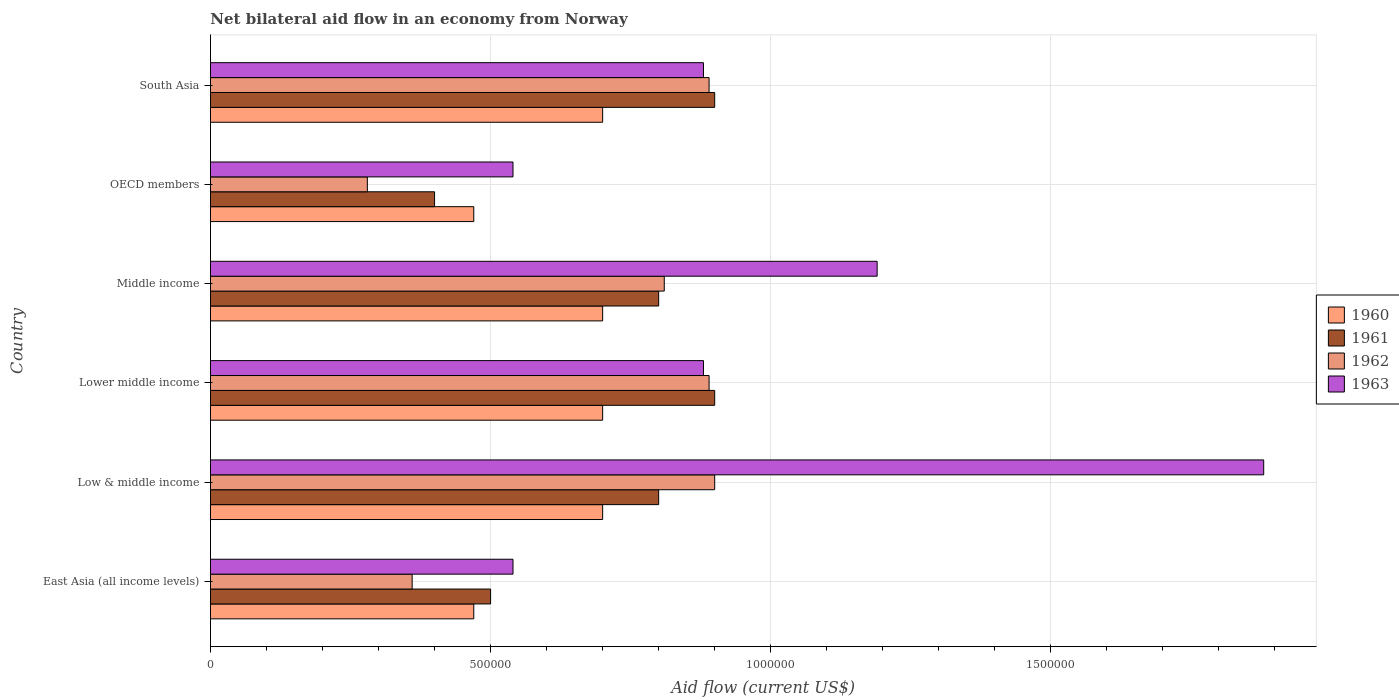How many groups of bars are there?
Provide a short and direct response. 6. Are the number of bars per tick equal to the number of legend labels?
Your response must be concise. Yes. What is the label of the 6th group of bars from the top?
Give a very brief answer. East Asia (all income levels). What is the net bilateral aid flow in 1963 in Lower middle income?
Your response must be concise. 8.80e+05. Across all countries, what is the minimum net bilateral aid flow in 1961?
Provide a short and direct response. 4.00e+05. In which country was the net bilateral aid flow in 1963 minimum?
Your answer should be very brief. East Asia (all income levels). What is the total net bilateral aid flow in 1960 in the graph?
Make the answer very short. 3.74e+06. What is the difference between the net bilateral aid flow in 1960 in East Asia (all income levels) and that in OECD members?
Keep it short and to the point. 0. What is the difference between the net bilateral aid flow in 1962 in OECD members and the net bilateral aid flow in 1960 in Middle income?
Give a very brief answer. -4.20e+05. What is the average net bilateral aid flow in 1962 per country?
Your answer should be very brief. 6.88e+05. In how many countries, is the net bilateral aid flow in 1962 greater than 100000 US$?
Provide a short and direct response. 6. What is the difference between the highest and the second highest net bilateral aid flow in 1963?
Your answer should be very brief. 6.90e+05. What is the difference between the highest and the lowest net bilateral aid flow in 1960?
Offer a terse response. 2.30e+05. Is the sum of the net bilateral aid flow in 1960 in Low & middle income and Lower middle income greater than the maximum net bilateral aid flow in 1962 across all countries?
Make the answer very short. Yes. Is it the case that in every country, the sum of the net bilateral aid flow in 1960 and net bilateral aid flow in 1962 is greater than the sum of net bilateral aid flow in 1961 and net bilateral aid flow in 1963?
Give a very brief answer. No. Is it the case that in every country, the sum of the net bilateral aid flow in 1961 and net bilateral aid flow in 1960 is greater than the net bilateral aid flow in 1962?
Keep it short and to the point. Yes. How many bars are there?
Offer a terse response. 24. Are all the bars in the graph horizontal?
Your answer should be very brief. Yes. How many countries are there in the graph?
Offer a very short reply. 6. Are the values on the major ticks of X-axis written in scientific E-notation?
Offer a very short reply. No. Does the graph contain grids?
Offer a terse response. Yes. Where does the legend appear in the graph?
Provide a succinct answer. Center right. What is the title of the graph?
Ensure brevity in your answer.  Net bilateral aid flow in an economy from Norway. What is the Aid flow (current US$) in 1963 in East Asia (all income levels)?
Keep it short and to the point. 5.40e+05. What is the Aid flow (current US$) of 1960 in Low & middle income?
Offer a terse response. 7.00e+05. What is the Aid flow (current US$) of 1961 in Low & middle income?
Keep it short and to the point. 8.00e+05. What is the Aid flow (current US$) of 1963 in Low & middle income?
Offer a very short reply. 1.88e+06. What is the Aid flow (current US$) in 1960 in Lower middle income?
Provide a succinct answer. 7.00e+05. What is the Aid flow (current US$) of 1961 in Lower middle income?
Your answer should be very brief. 9.00e+05. What is the Aid flow (current US$) in 1962 in Lower middle income?
Keep it short and to the point. 8.90e+05. What is the Aid flow (current US$) in 1963 in Lower middle income?
Your response must be concise. 8.80e+05. What is the Aid flow (current US$) of 1962 in Middle income?
Ensure brevity in your answer.  8.10e+05. What is the Aid flow (current US$) in 1963 in Middle income?
Keep it short and to the point. 1.19e+06. What is the Aid flow (current US$) of 1960 in OECD members?
Offer a very short reply. 4.70e+05. What is the Aid flow (current US$) of 1961 in OECD members?
Provide a short and direct response. 4.00e+05. What is the Aid flow (current US$) in 1962 in OECD members?
Make the answer very short. 2.80e+05. What is the Aid flow (current US$) of 1963 in OECD members?
Your response must be concise. 5.40e+05. What is the Aid flow (current US$) in 1960 in South Asia?
Your answer should be compact. 7.00e+05. What is the Aid flow (current US$) in 1961 in South Asia?
Your answer should be very brief. 9.00e+05. What is the Aid flow (current US$) of 1962 in South Asia?
Ensure brevity in your answer.  8.90e+05. What is the Aid flow (current US$) of 1963 in South Asia?
Give a very brief answer. 8.80e+05. Across all countries, what is the maximum Aid flow (current US$) of 1960?
Offer a very short reply. 7.00e+05. Across all countries, what is the maximum Aid flow (current US$) of 1962?
Provide a succinct answer. 9.00e+05. Across all countries, what is the maximum Aid flow (current US$) in 1963?
Your answer should be very brief. 1.88e+06. Across all countries, what is the minimum Aid flow (current US$) of 1960?
Your answer should be compact. 4.70e+05. Across all countries, what is the minimum Aid flow (current US$) in 1961?
Your response must be concise. 4.00e+05. Across all countries, what is the minimum Aid flow (current US$) of 1962?
Provide a short and direct response. 2.80e+05. Across all countries, what is the minimum Aid flow (current US$) in 1963?
Provide a short and direct response. 5.40e+05. What is the total Aid flow (current US$) of 1960 in the graph?
Your answer should be compact. 3.74e+06. What is the total Aid flow (current US$) of 1961 in the graph?
Make the answer very short. 4.30e+06. What is the total Aid flow (current US$) of 1962 in the graph?
Give a very brief answer. 4.13e+06. What is the total Aid flow (current US$) in 1963 in the graph?
Offer a terse response. 5.91e+06. What is the difference between the Aid flow (current US$) in 1962 in East Asia (all income levels) and that in Low & middle income?
Ensure brevity in your answer.  -5.40e+05. What is the difference between the Aid flow (current US$) of 1963 in East Asia (all income levels) and that in Low & middle income?
Your response must be concise. -1.34e+06. What is the difference between the Aid flow (current US$) in 1960 in East Asia (all income levels) and that in Lower middle income?
Offer a terse response. -2.30e+05. What is the difference between the Aid flow (current US$) in 1961 in East Asia (all income levels) and that in Lower middle income?
Your answer should be compact. -4.00e+05. What is the difference between the Aid flow (current US$) of 1962 in East Asia (all income levels) and that in Lower middle income?
Make the answer very short. -5.30e+05. What is the difference between the Aid flow (current US$) of 1963 in East Asia (all income levels) and that in Lower middle income?
Provide a succinct answer. -3.40e+05. What is the difference between the Aid flow (current US$) of 1962 in East Asia (all income levels) and that in Middle income?
Your answer should be compact. -4.50e+05. What is the difference between the Aid flow (current US$) of 1963 in East Asia (all income levels) and that in Middle income?
Provide a succinct answer. -6.50e+05. What is the difference between the Aid flow (current US$) in 1961 in East Asia (all income levels) and that in OECD members?
Provide a short and direct response. 1.00e+05. What is the difference between the Aid flow (current US$) of 1962 in East Asia (all income levels) and that in OECD members?
Provide a succinct answer. 8.00e+04. What is the difference between the Aid flow (current US$) of 1961 in East Asia (all income levels) and that in South Asia?
Keep it short and to the point. -4.00e+05. What is the difference between the Aid flow (current US$) in 1962 in East Asia (all income levels) and that in South Asia?
Offer a terse response. -5.30e+05. What is the difference between the Aid flow (current US$) of 1961 in Low & middle income and that in Middle income?
Provide a succinct answer. 0. What is the difference between the Aid flow (current US$) of 1963 in Low & middle income and that in Middle income?
Offer a very short reply. 6.90e+05. What is the difference between the Aid flow (current US$) in 1960 in Low & middle income and that in OECD members?
Ensure brevity in your answer.  2.30e+05. What is the difference between the Aid flow (current US$) of 1962 in Low & middle income and that in OECD members?
Make the answer very short. 6.20e+05. What is the difference between the Aid flow (current US$) of 1963 in Low & middle income and that in OECD members?
Offer a terse response. 1.34e+06. What is the difference between the Aid flow (current US$) of 1960 in Low & middle income and that in South Asia?
Your answer should be compact. 0. What is the difference between the Aid flow (current US$) of 1963 in Low & middle income and that in South Asia?
Provide a succinct answer. 1.00e+06. What is the difference between the Aid flow (current US$) in 1960 in Lower middle income and that in Middle income?
Your answer should be very brief. 0. What is the difference between the Aid flow (current US$) in 1961 in Lower middle income and that in Middle income?
Offer a terse response. 1.00e+05. What is the difference between the Aid flow (current US$) in 1962 in Lower middle income and that in Middle income?
Give a very brief answer. 8.00e+04. What is the difference between the Aid flow (current US$) of 1963 in Lower middle income and that in Middle income?
Make the answer very short. -3.10e+05. What is the difference between the Aid flow (current US$) of 1961 in Lower middle income and that in OECD members?
Your answer should be very brief. 5.00e+05. What is the difference between the Aid flow (current US$) in 1962 in Lower middle income and that in OECD members?
Ensure brevity in your answer.  6.10e+05. What is the difference between the Aid flow (current US$) of 1963 in Lower middle income and that in OECD members?
Your response must be concise. 3.40e+05. What is the difference between the Aid flow (current US$) of 1960 in Lower middle income and that in South Asia?
Your response must be concise. 0. What is the difference between the Aid flow (current US$) in 1962 in Lower middle income and that in South Asia?
Offer a very short reply. 0. What is the difference between the Aid flow (current US$) in 1963 in Lower middle income and that in South Asia?
Offer a terse response. 0. What is the difference between the Aid flow (current US$) of 1962 in Middle income and that in OECD members?
Give a very brief answer. 5.30e+05. What is the difference between the Aid flow (current US$) in 1963 in Middle income and that in OECD members?
Your answer should be compact. 6.50e+05. What is the difference between the Aid flow (current US$) in 1963 in Middle income and that in South Asia?
Ensure brevity in your answer.  3.10e+05. What is the difference between the Aid flow (current US$) in 1960 in OECD members and that in South Asia?
Your response must be concise. -2.30e+05. What is the difference between the Aid flow (current US$) of 1961 in OECD members and that in South Asia?
Offer a terse response. -5.00e+05. What is the difference between the Aid flow (current US$) of 1962 in OECD members and that in South Asia?
Your response must be concise. -6.10e+05. What is the difference between the Aid flow (current US$) of 1963 in OECD members and that in South Asia?
Keep it short and to the point. -3.40e+05. What is the difference between the Aid flow (current US$) in 1960 in East Asia (all income levels) and the Aid flow (current US$) in 1961 in Low & middle income?
Offer a terse response. -3.30e+05. What is the difference between the Aid flow (current US$) in 1960 in East Asia (all income levels) and the Aid flow (current US$) in 1962 in Low & middle income?
Your response must be concise. -4.30e+05. What is the difference between the Aid flow (current US$) in 1960 in East Asia (all income levels) and the Aid flow (current US$) in 1963 in Low & middle income?
Ensure brevity in your answer.  -1.41e+06. What is the difference between the Aid flow (current US$) in 1961 in East Asia (all income levels) and the Aid flow (current US$) in 1962 in Low & middle income?
Provide a short and direct response. -4.00e+05. What is the difference between the Aid flow (current US$) of 1961 in East Asia (all income levels) and the Aid flow (current US$) of 1963 in Low & middle income?
Offer a terse response. -1.38e+06. What is the difference between the Aid flow (current US$) of 1962 in East Asia (all income levels) and the Aid flow (current US$) of 1963 in Low & middle income?
Keep it short and to the point. -1.52e+06. What is the difference between the Aid flow (current US$) in 1960 in East Asia (all income levels) and the Aid flow (current US$) in 1961 in Lower middle income?
Your response must be concise. -4.30e+05. What is the difference between the Aid flow (current US$) of 1960 in East Asia (all income levels) and the Aid flow (current US$) of 1962 in Lower middle income?
Offer a very short reply. -4.20e+05. What is the difference between the Aid flow (current US$) in 1960 in East Asia (all income levels) and the Aid flow (current US$) in 1963 in Lower middle income?
Offer a very short reply. -4.10e+05. What is the difference between the Aid flow (current US$) in 1961 in East Asia (all income levels) and the Aid flow (current US$) in 1962 in Lower middle income?
Make the answer very short. -3.90e+05. What is the difference between the Aid flow (current US$) in 1961 in East Asia (all income levels) and the Aid flow (current US$) in 1963 in Lower middle income?
Your answer should be compact. -3.80e+05. What is the difference between the Aid flow (current US$) in 1962 in East Asia (all income levels) and the Aid flow (current US$) in 1963 in Lower middle income?
Make the answer very short. -5.20e+05. What is the difference between the Aid flow (current US$) of 1960 in East Asia (all income levels) and the Aid flow (current US$) of 1961 in Middle income?
Your answer should be very brief. -3.30e+05. What is the difference between the Aid flow (current US$) of 1960 in East Asia (all income levels) and the Aid flow (current US$) of 1963 in Middle income?
Offer a very short reply. -7.20e+05. What is the difference between the Aid flow (current US$) in 1961 in East Asia (all income levels) and the Aid flow (current US$) in 1962 in Middle income?
Give a very brief answer. -3.10e+05. What is the difference between the Aid flow (current US$) of 1961 in East Asia (all income levels) and the Aid flow (current US$) of 1963 in Middle income?
Provide a succinct answer. -6.90e+05. What is the difference between the Aid flow (current US$) of 1962 in East Asia (all income levels) and the Aid flow (current US$) of 1963 in Middle income?
Make the answer very short. -8.30e+05. What is the difference between the Aid flow (current US$) of 1961 in East Asia (all income levels) and the Aid flow (current US$) of 1962 in OECD members?
Ensure brevity in your answer.  2.20e+05. What is the difference between the Aid flow (current US$) of 1961 in East Asia (all income levels) and the Aid flow (current US$) of 1963 in OECD members?
Your answer should be compact. -4.00e+04. What is the difference between the Aid flow (current US$) in 1962 in East Asia (all income levels) and the Aid flow (current US$) in 1963 in OECD members?
Your answer should be compact. -1.80e+05. What is the difference between the Aid flow (current US$) of 1960 in East Asia (all income levels) and the Aid flow (current US$) of 1961 in South Asia?
Offer a terse response. -4.30e+05. What is the difference between the Aid flow (current US$) of 1960 in East Asia (all income levels) and the Aid flow (current US$) of 1962 in South Asia?
Offer a very short reply. -4.20e+05. What is the difference between the Aid flow (current US$) of 1960 in East Asia (all income levels) and the Aid flow (current US$) of 1963 in South Asia?
Provide a short and direct response. -4.10e+05. What is the difference between the Aid flow (current US$) in 1961 in East Asia (all income levels) and the Aid flow (current US$) in 1962 in South Asia?
Your response must be concise. -3.90e+05. What is the difference between the Aid flow (current US$) in 1961 in East Asia (all income levels) and the Aid flow (current US$) in 1963 in South Asia?
Keep it short and to the point. -3.80e+05. What is the difference between the Aid flow (current US$) of 1962 in East Asia (all income levels) and the Aid flow (current US$) of 1963 in South Asia?
Ensure brevity in your answer.  -5.20e+05. What is the difference between the Aid flow (current US$) of 1960 in Low & middle income and the Aid flow (current US$) of 1961 in Lower middle income?
Your response must be concise. -2.00e+05. What is the difference between the Aid flow (current US$) in 1961 in Low & middle income and the Aid flow (current US$) in 1963 in Lower middle income?
Make the answer very short. -8.00e+04. What is the difference between the Aid flow (current US$) in 1962 in Low & middle income and the Aid flow (current US$) in 1963 in Lower middle income?
Your answer should be compact. 2.00e+04. What is the difference between the Aid flow (current US$) in 1960 in Low & middle income and the Aid flow (current US$) in 1962 in Middle income?
Make the answer very short. -1.10e+05. What is the difference between the Aid flow (current US$) of 1960 in Low & middle income and the Aid flow (current US$) of 1963 in Middle income?
Offer a terse response. -4.90e+05. What is the difference between the Aid flow (current US$) of 1961 in Low & middle income and the Aid flow (current US$) of 1963 in Middle income?
Offer a very short reply. -3.90e+05. What is the difference between the Aid flow (current US$) in 1962 in Low & middle income and the Aid flow (current US$) in 1963 in Middle income?
Your answer should be very brief. -2.90e+05. What is the difference between the Aid flow (current US$) in 1960 in Low & middle income and the Aid flow (current US$) in 1962 in OECD members?
Your answer should be very brief. 4.20e+05. What is the difference between the Aid flow (current US$) in 1960 in Low & middle income and the Aid flow (current US$) in 1963 in OECD members?
Your answer should be compact. 1.60e+05. What is the difference between the Aid flow (current US$) of 1961 in Low & middle income and the Aid flow (current US$) of 1962 in OECD members?
Provide a short and direct response. 5.20e+05. What is the difference between the Aid flow (current US$) of 1960 in Low & middle income and the Aid flow (current US$) of 1961 in South Asia?
Keep it short and to the point. -2.00e+05. What is the difference between the Aid flow (current US$) of 1960 in Low & middle income and the Aid flow (current US$) of 1962 in South Asia?
Your response must be concise. -1.90e+05. What is the difference between the Aid flow (current US$) of 1962 in Low & middle income and the Aid flow (current US$) of 1963 in South Asia?
Offer a terse response. 2.00e+04. What is the difference between the Aid flow (current US$) of 1960 in Lower middle income and the Aid flow (current US$) of 1961 in Middle income?
Make the answer very short. -1.00e+05. What is the difference between the Aid flow (current US$) in 1960 in Lower middle income and the Aid flow (current US$) in 1963 in Middle income?
Ensure brevity in your answer.  -4.90e+05. What is the difference between the Aid flow (current US$) in 1961 in Lower middle income and the Aid flow (current US$) in 1962 in Middle income?
Provide a succinct answer. 9.00e+04. What is the difference between the Aid flow (current US$) of 1960 in Lower middle income and the Aid flow (current US$) of 1961 in OECD members?
Offer a terse response. 3.00e+05. What is the difference between the Aid flow (current US$) of 1961 in Lower middle income and the Aid flow (current US$) of 1962 in OECD members?
Ensure brevity in your answer.  6.20e+05. What is the difference between the Aid flow (current US$) in 1961 in Lower middle income and the Aid flow (current US$) in 1963 in OECD members?
Your answer should be compact. 3.60e+05. What is the difference between the Aid flow (current US$) in 1962 in Lower middle income and the Aid flow (current US$) in 1963 in OECD members?
Give a very brief answer. 3.50e+05. What is the difference between the Aid flow (current US$) of 1960 in Lower middle income and the Aid flow (current US$) of 1963 in South Asia?
Provide a short and direct response. -1.80e+05. What is the difference between the Aid flow (current US$) in 1961 in Lower middle income and the Aid flow (current US$) in 1963 in South Asia?
Make the answer very short. 2.00e+04. What is the difference between the Aid flow (current US$) in 1960 in Middle income and the Aid flow (current US$) in 1961 in OECD members?
Provide a succinct answer. 3.00e+05. What is the difference between the Aid flow (current US$) in 1960 in Middle income and the Aid flow (current US$) in 1962 in OECD members?
Provide a succinct answer. 4.20e+05. What is the difference between the Aid flow (current US$) of 1961 in Middle income and the Aid flow (current US$) of 1962 in OECD members?
Ensure brevity in your answer.  5.20e+05. What is the difference between the Aid flow (current US$) of 1960 in Middle income and the Aid flow (current US$) of 1963 in South Asia?
Offer a very short reply. -1.80e+05. What is the difference between the Aid flow (current US$) in 1961 in Middle income and the Aid flow (current US$) in 1963 in South Asia?
Your answer should be very brief. -8.00e+04. What is the difference between the Aid flow (current US$) in 1960 in OECD members and the Aid flow (current US$) in 1961 in South Asia?
Offer a very short reply. -4.30e+05. What is the difference between the Aid flow (current US$) in 1960 in OECD members and the Aid flow (current US$) in 1962 in South Asia?
Offer a very short reply. -4.20e+05. What is the difference between the Aid flow (current US$) of 1960 in OECD members and the Aid flow (current US$) of 1963 in South Asia?
Your response must be concise. -4.10e+05. What is the difference between the Aid flow (current US$) in 1961 in OECD members and the Aid flow (current US$) in 1962 in South Asia?
Your answer should be very brief. -4.90e+05. What is the difference between the Aid flow (current US$) in 1961 in OECD members and the Aid flow (current US$) in 1963 in South Asia?
Your answer should be very brief. -4.80e+05. What is the difference between the Aid flow (current US$) of 1962 in OECD members and the Aid flow (current US$) of 1963 in South Asia?
Provide a short and direct response. -6.00e+05. What is the average Aid flow (current US$) in 1960 per country?
Keep it short and to the point. 6.23e+05. What is the average Aid flow (current US$) in 1961 per country?
Give a very brief answer. 7.17e+05. What is the average Aid flow (current US$) in 1962 per country?
Ensure brevity in your answer.  6.88e+05. What is the average Aid flow (current US$) of 1963 per country?
Offer a very short reply. 9.85e+05. What is the difference between the Aid flow (current US$) in 1960 and Aid flow (current US$) in 1961 in East Asia (all income levels)?
Provide a short and direct response. -3.00e+04. What is the difference between the Aid flow (current US$) in 1960 and Aid flow (current US$) in 1962 in East Asia (all income levels)?
Keep it short and to the point. 1.10e+05. What is the difference between the Aid flow (current US$) in 1961 and Aid flow (current US$) in 1962 in East Asia (all income levels)?
Provide a short and direct response. 1.40e+05. What is the difference between the Aid flow (current US$) of 1961 and Aid flow (current US$) of 1963 in East Asia (all income levels)?
Offer a terse response. -4.00e+04. What is the difference between the Aid flow (current US$) of 1960 and Aid flow (current US$) of 1961 in Low & middle income?
Provide a short and direct response. -1.00e+05. What is the difference between the Aid flow (current US$) in 1960 and Aid flow (current US$) in 1963 in Low & middle income?
Your answer should be very brief. -1.18e+06. What is the difference between the Aid flow (current US$) of 1961 and Aid flow (current US$) of 1963 in Low & middle income?
Ensure brevity in your answer.  -1.08e+06. What is the difference between the Aid flow (current US$) of 1962 and Aid flow (current US$) of 1963 in Low & middle income?
Provide a short and direct response. -9.80e+05. What is the difference between the Aid flow (current US$) of 1961 and Aid flow (current US$) of 1962 in Lower middle income?
Provide a succinct answer. 10000. What is the difference between the Aid flow (current US$) of 1960 and Aid flow (current US$) of 1962 in Middle income?
Your answer should be very brief. -1.10e+05. What is the difference between the Aid flow (current US$) in 1960 and Aid flow (current US$) in 1963 in Middle income?
Keep it short and to the point. -4.90e+05. What is the difference between the Aid flow (current US$) of 1961 and Aid flow (current US$) of 1962 in Middle income?
Offer a very short reply. -10000. What is the difference between the Aid flow (current US$) of 1961 and Aid flow (current US$) of 1963 in Middle income?
Offer a very short reply. -3.90e+05. What is the difference between the Aid flow (current US$) in 1962 and Aid flow (current US$) in 1963 in Middle income?
Your response must be concise. -3.80e+05. What is the difference between the Aid flow (current US$) of 1960 and Aid flow (current US$) of 1962 in OECD members?
Your answer should be very brief. 1.90e+05. What is the difference between the Aid flow (current US$) of 1961 and Aid flow (current US$) of 1962 in OECD members?
Provide a short and direct response. 1.20e+05. What is the difference between the Aid flow (current US$) of 1961 and Aid flow (current US$) of 1963 in OECD members?
Your answer should be compact. -1.40e+05. What is the difference between the Aid flow (current US$) in 1962 and Aid flow (current US$) in 1963 in OECD members?
Provide a succinct answer. -2.60e+05. What is the difference between the Aid flow (current US$) in 1961 and Aid flow (current US$) in 1962 in South Asia?
Offer a terse response. 10000. What is the difference between the Aid flow (current US$) in 1961 and Aid flow (current US$) in 1963 in South Asia?
Make the answer very short. 2.00e+04. What is the difference between the Aid flow (current US$) of 1962 and Aid flow (current US$) of 1963 in South Asia?
Provide a short and direct response. 10000. What is the ratio of the Aid flow (current US$) in 1960 in East Asia (all income levels) to that in Low & middle income?
Your answer should be very brief. 0.67. What is the ratio of the Aid flow (current US$) in 1961 in East Asia (all income levels) to that in Low & middle income?
Provide a succinct answer. 0.62. What is the ratio of the Aid flow (current US$) in 1962 in East Asia (all income levels) to that in Low & middle income?
Keep it short and to the point. 0.4. What is the ratio of the Aid flow (current US$) in 1963 in East Asia (all income levels) to that in Low & middle income?
Keep it short and to the point. 0.29. What is the ratio of the Aid flow (current US$) in 1960 in East Asia (all income levels) to that in Lower middle income?
Provide a succinct answer. 0.67. What is the ratio of the Aid flow (current US$) in 1961 in East Asia (all income levels) to that in Lower middle income?
Give a very brief answer. 0.56. What is the ratio of the Aid flow (current US$) of 1962 in East Asia (all income levels) to that in Lower middle income?
Ensure brevity in your answer.  0.4. What is the ratio of the Aid flow (current US$) of 1963 in East Asia (all income levels) to that in Lower middle income?
Your answer should be compact. 0.61. What is the ratio of the Aid flow (current US$) of 1960 in East Asia (all income levels) to that in Middle income?
Ensure brevity in your answer.  0.67. What is the ratio of the Aid flow (current US$) in 1961 in East Asia (all income levels) to that in Middle income?
Your answer should be very brief. 0.62. What is the ratio of the Aid flow (current US$) in 1962 in East Asia (all income levels) to that in Middle income?
Offer a terse response. 0.44. What is the ratio of the Aid flow (current US$) of 1963 in East Asia (all income levels) to that in Middle income?
Your response must be concise. 0.45. What is the ratio of the Aid flow (current US$) of 1960 in East Asia (all income levels) to that in OECD members?
Give a very brief answer. 1. What is the ratio of the Aid flow (current US$) in 1962 in East Asia (all income levels) to that in OECD members?
Make the answer very short. 1.29. What is the ratio of the Aid flow (current US$) of 1963 in East Asia (all income levels) to that in OECD members?
Your answer should be very brief. 1. What is the ratio of the Aid flow (current US$) of 1960 in East Asia (all income levels) to that in South Asia?
Your answer should be very brief. 0.67. What is the ratio of the Aid flow (current US$) of 1961 in East Asia (all income levels) to that in South Asia?
Your answer should be compact. 0.56. What is the ratio of the Aid flow (current US$) in 1962 in East Asia (all income levels) to that in South Asia?
Your response must be concise. 0.4. What is the ratio of the Aid flow (current US$) in 1963 in East Asia (all income levels) to that in South Asia?
Provide a short and direct response. 0.61. What is the ratio of the Aid flow (current US$) in 1961 in Low & middle income to that in Lower middle income?
Your answer should be very brief. 0.89. What is the ratio of the Aid flow (current US$) of 1962 in Low & middle income to that in Lower middle income?
Keep it short and to the point. 1.01. What is the ratio of the Aid flow (current US$) in 1963 in Low & middle income to that in Lower middle income?
Ensure brevity in your answer.  2.14. What is the ratio of the Aid flow (current US$) of 1960 in Low & middle income to that in Middle income?
Your response must be concise. 1. What is the ratio of the Aid flow (current US$) in 1962 in Low & middle income to that in Middle income?
Offer a very short reply. 1.11. What is the ratio of the Aid flow (current US$) in 1963 in Low & middle income to that in Middle income?
Offer a very short reply. 1.58. What is the ratio of the Aid flow (current US$) in 1960 in Low & middle income to that in OECD members?
Your answer should be very brief. 1.49. What is the ratio of the Aid flow (current US$) of 1962 in Low & middle income to that in OECD members?
Keep it short and to the point. 3.21. What is the ratio of the Aid flow (current US$) of 1963 in Low & middle income to that in OECD members?
Provide a short and direct response. 3.48. What is the ratio of the Aid flow (current US$) in 1960 in Low & middle income to that in South Asia?
Ensure brevity in your answer.  1. What is the ratio of the Aid flow (current US$) in 1961 in Low & middle income to that in South Asia?
Give a very brief answer. 0.89. What is the ratio of the Aid flow (current US$) of 1962 in Low & middle income to that in South Asia?
Give a very brief answer. 1.01. What is the ratio of the Aid flow (current US$) of 1963 in Low & middle income to that in South Asia?
Offer a very short reply. 2.14. What is the ratio of the Aid flow (current US$) of 1960 in Lower middle income to that in Middle income?
Your response must be concise. 1. What is the ratio of the Aid flow (current US$) in 1961 in Lower middle income to that in Middle income?
Offer a terse response. 1.12. What is the ratio of the Aid flow (current US$) of 1962 in Lower middle income to that in Middle income?
Your response must be concise. 1.1. What is the ratio of the Aid flow (current US$) in 1963 in Lower middle income to that in Middle income?
Your answer should be compact. 0.74. What is the ratio of the Aid flow (current US$) of 1960 in Lower middle income to that in OECD members?
Offer a terse response. 1.49. What is the ratio of the Aid flow (current US$) in 1961 in Lower middle income to that in OECD members?
Offer a terse response. 2.25. What is the ratio of the Aid flow (current US$) in 1962 in Lower middle income to that in OECD members?
Your answer should be very brief. 3.18. What is the ratio of the Aid flow (current US$) of 1963 in Lower middle income to that in OECD members?
Make the answer very short. 1.63. What is the ratio of the Aid flow (current US$) of 1960 in Lower middle income to that in South Asia?
Ensure brevity in your answer.  1. What is the ratio of the Aid flow (current US$) of 1962 in Lower middle income to that in South Asia?
Provide a short and direct response. 1. What is the ratio of the Aid flow (current US$) in 1960 in Middle income to that in OECD members?
Provide a succinct answer. 1.49. What is the ratio of the Aid flow (current US$) in 1962 in Middle income to that in OECD members?
Offer a very short reply. 2.89. What is the ratio of the Aid flow (current US$) in 1963 in Middle income to that in OECD members?
Offer a terse response. 2.2. What is the ratio of the Aid flow (current US$) in 1961 in Middle income to that in South Asia?
Offer a terse response. 0.89. What is the ratio of the Aid flow (current US$) in 1962 in Middle income to that in South Asia?
Your answer should be compact. 0.91. What is the ratio of the Aid flow (current US$) of 1963 in Middle income to that in South Asia?
Keep it short and to the point. 1.35. What is the ratio of the Aid flow (current US$) in 1960 in OECD members to that in South Asia?
Provide a succinct answer. 0.67. What is the ratio of the Aid flow (current US$) of 1961 in OECD members to that in South Asia?
Your answer should be compact. 0.44. What is the ratio of the Aid flow (current US$) in 1962 in OECD members to that in South Asia?
Keep it short and to the point. 0.31. What is the ratio of the Aid flow (current US$) in 1963 in OECD members to that in South Asia?
Offer a terse response. 0.61. What is the difference between the highest and the second highest Aid flow (current US$) in 1963?
Offer a terse response. 6.90e+05. What is the difference between the highest and the lowest Aid flow (current US$) of 1960?
Offer a terse response. 2.30e+05. What is the difference between the highest and the lowest Aid flow (current US$) in 1961?
Offer a terse response. 5.00e+05. What is the difference between the highest and the lowest Aid flow (current US$) of 1962?
Provide a succinct answer. 6.20e+05. What is the difference between the highest and the lowest Aid flow (current US$) in 1963?
Ensure brevity in your answer.  1.34e+06. 